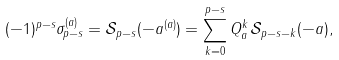<formula> <loc_0><loc_0><loc_500><loc_500>( - 1 ) ^ { p - s } \sigma _ { p - s } ^ { ( a ) } = \mathcal { S } _ { p - s } ( - a ^ { ( a ) } ) = \sum _ { k = 0 } ^ { p - s } Q _ { a } ^ { k } \, \mathcal { S } _ { p - s - k } ( - a ) ,</formula> 